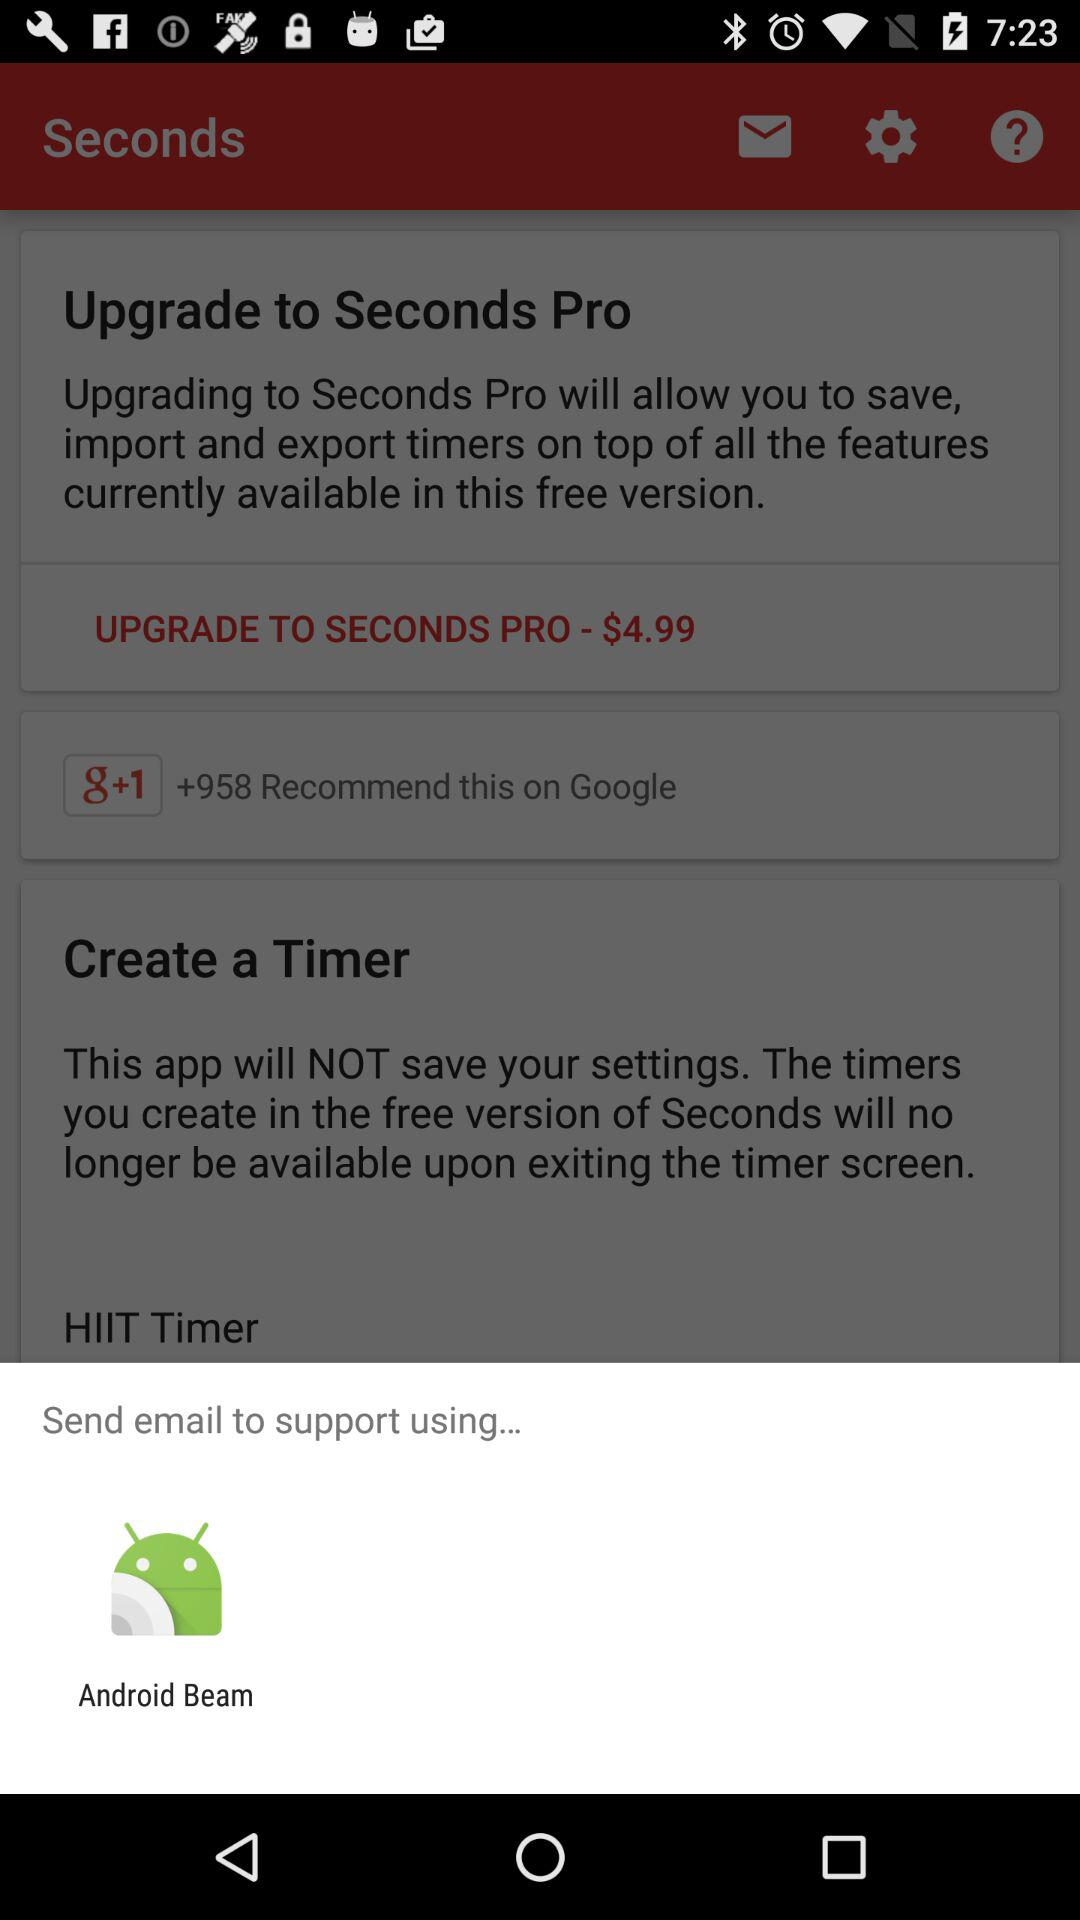What application can be used to send an email to the support? The application that can be used to send an email to the support is "Android Beam". 